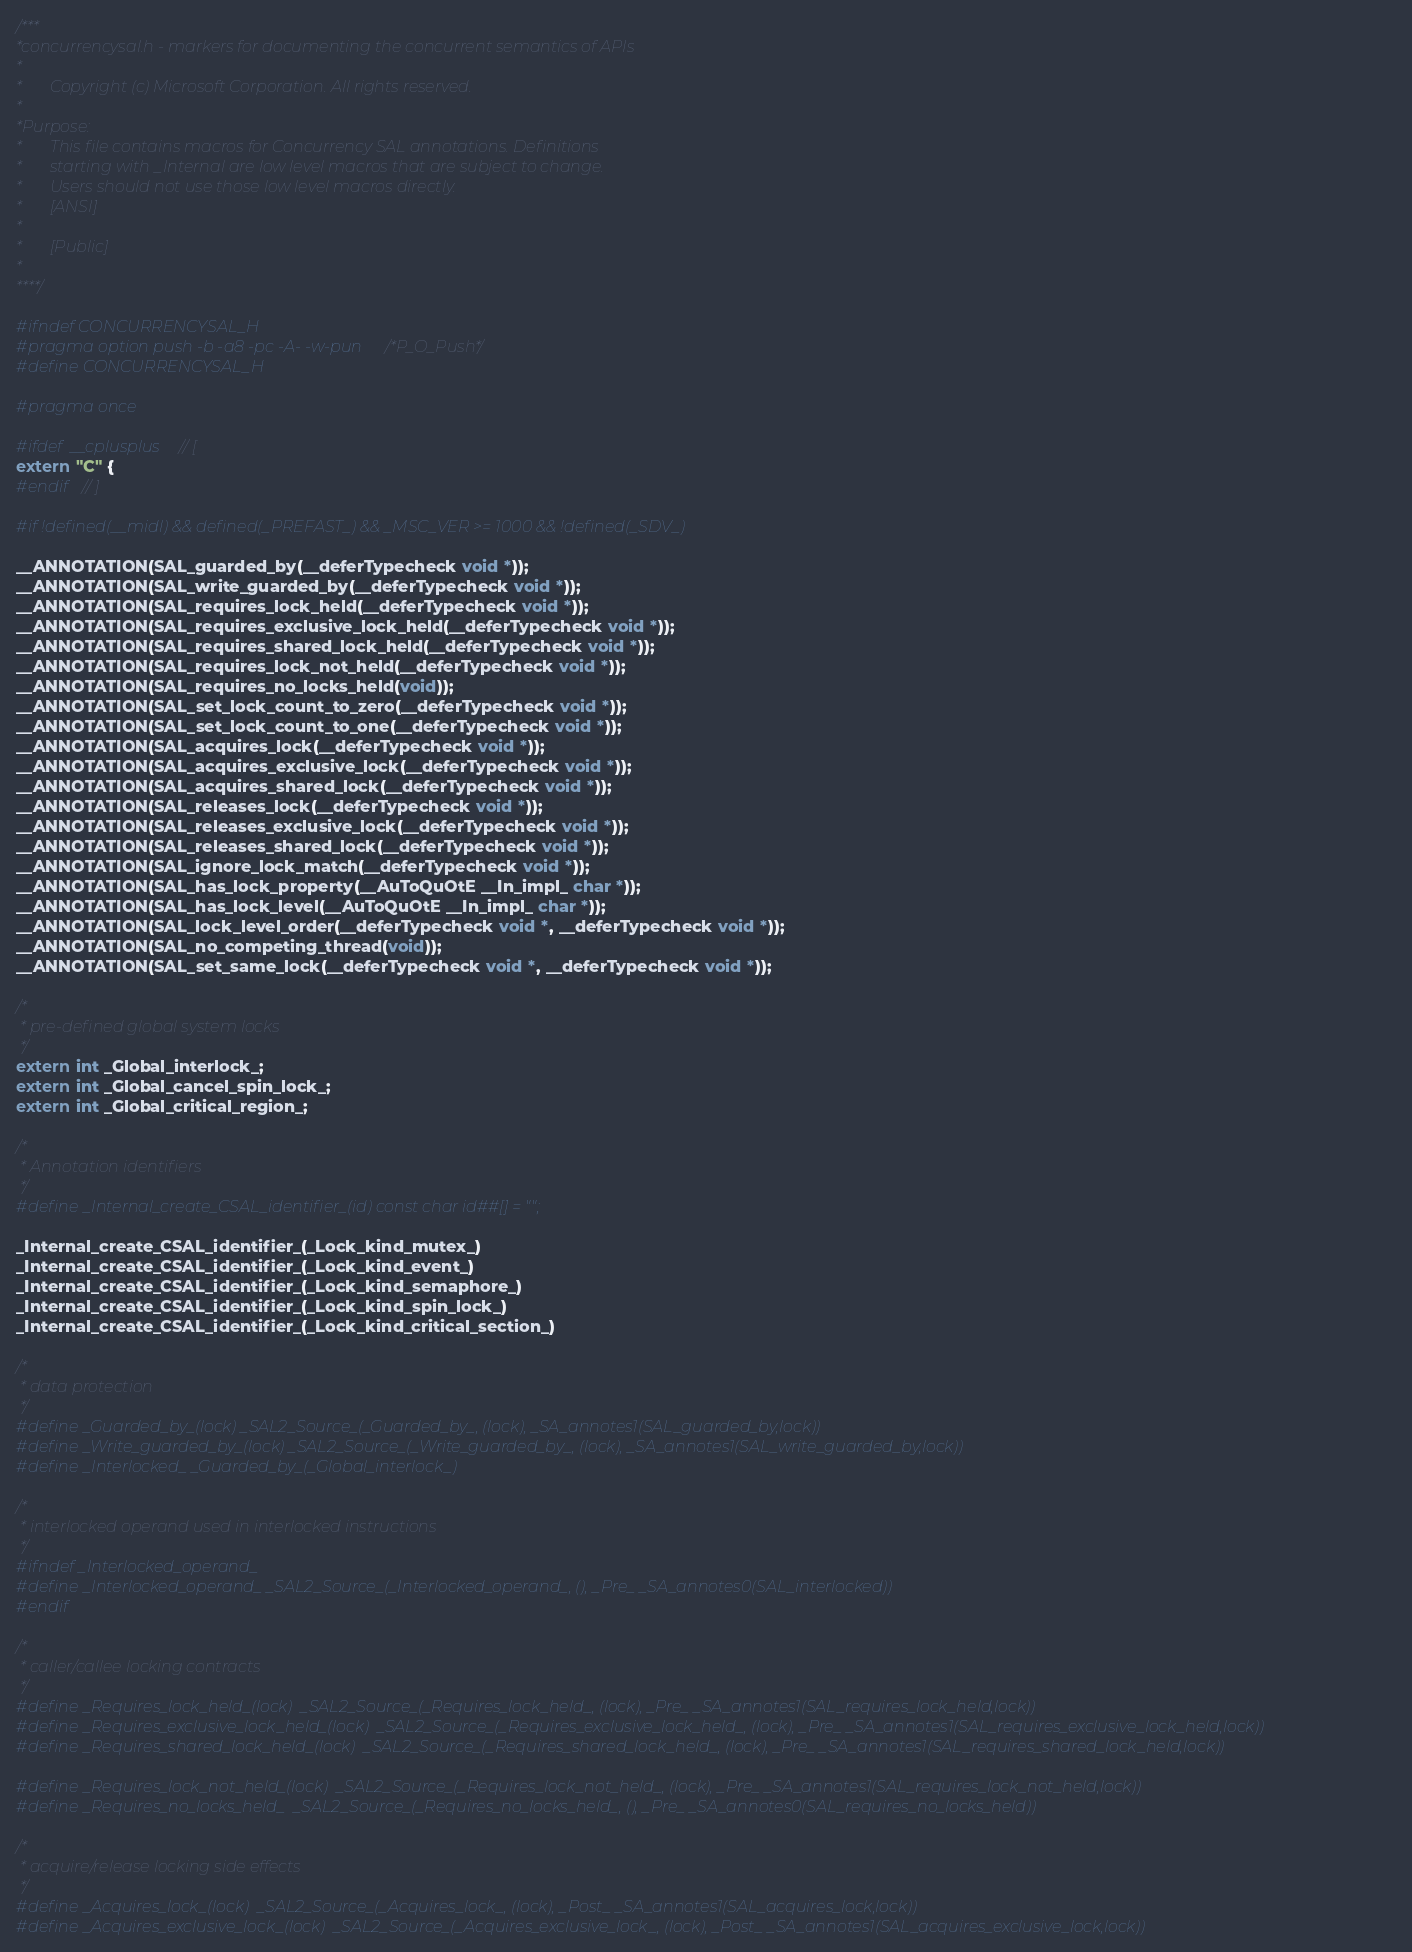Convert code to text. <code><loc_0><loc_0><loc_500><loc_500><_C_>/***
*concurrencysal.h - markers for documenting the concurrent semantics of APIs
*
*       Copyright (c) Microsoft Corporation. All rights reserved.
*
*Purpose:
*       This file contains macros for Concurrency SAL annotations. Definitions
*       starting with _Internal are low level macros that are subject to change. 
*       Users should not use those low level macros directly.
*       [ANSI]
*
*       [Public]
*
****/

#ifndef CONCURRENCYSAL_H
#pragma option push -b -a8 -pc -A- -w-pun /*P_O_Push*/
#define CONCURRENCYSAL_H

#pragma once

#ifdef  __cplusplus // [
extern "C" {
#endif  // ]

#if !defined(__midl) && defined(_PREFAST_) && _MSC_VER >= 1000 && !defined(_SDV_)

__ANNOTATION(SAL_guarded_by(__deferTypecheck void *));
__ANNOTATION(SAL_write_guarded_by(__deferTypecheck void *));
__ANNOTATION(SAL_requires_lock_held(__deferTypecheck void *));
__ANNOTATION(SAL_requires_exclusive_lock_held(__deferTypecheck void *));
__ANNOTATION(SAL_requires_shared_lock_held(__deferTypecheck void *));
__ANNOTATION(SAL_requires_lock_not_held(__deferTypecheck void *));
__ANNOTATION(SAL_requires_no_locks_held(void));
__ANNOTATION(SAL_set_lock_count_to_zero(__deferTypecheck void *));
__ANNOTATION(SAL_set_lock_count_to_one(__deferTypecheck void *));
__ANNOTATION(SAL_acquires_lock(__deferTypecheck void *));
__ANNOTATION(SAL_acquires_exclusive_lock(__deferTypecheck void *));
__ANNOTATION(SAL_acquires_shared_lock(__deferTypecheck void *));
__ANNOTATION(SAL_releases_lock(__deferTypecheck void *));
__ANNOTATION(SAL_releases_exclusive_lock(__deferTypecheck void *));
__ANNOTATION(SAL_releases_shared_lock(__deferTypecheck void *));
__ANNOTATION(SAL_ignore_lock_match(__deferTypecheck void *));
__ANNOTATION(SAL_has_lock_property(__AuToQuOtE __In_impl_ char *));
__ANNOTATION(SAL_has_lock_level(__AuToQuOtE __In_impl_ char *));
__ANNOTATION(SAL_lock_level_order(__deferTypecheck void *, __deferTypecheck void *));
__ANNOTATION(SAL_no_competing_thread(void));
__ANNOTATION(SAL_set_same_lock(__deferTypecheck void *, __deferTypecheck void *));

/*
 * pre-defined global system locks
 */
extern int _Global_interlock_;
extern int _Global_cancel_spin_lock_;
extern int _Global_critical_region_;

/*
 * Annotation identifiers
 */
#define _Internal_create_CSAL_identifier_(id) const char id##[] = "";

_Internal_create_CSAL_identifier_(_Lock_kind_mutex_)
_Internal_create_CSAL_identifier_(_Lock_kind_event_)
_Internal_create_CSAL_identifier_(_Lock_kind_semaphore_)
_Internal_create_CSAL_identifier_(_Lock_kind_spin_lock_)
_Internal_create_CSAL_identifier_(_Lock_kind_critical_section_)

/*
 * data protection
 */
#define _Guarded_by_(lock) _SAL2_Source_(_Guarded_by_, (lock), _SA_annotes1(SAL_guarded_by,lock))
#define _Write_guarded_by_(lock) _SAL2_Source_(_Write_guarded_by_, (lock), _SA_annotes1(SAL_write_guarded_by,lock))
#define _Interlocked_ _Guarded_by_(_Global_interlock_)

/*
 * interlocked operand used in interlocked instructions
 */
#ifndef _Interlocked_operand_
#define _Interlocked_operand_ _SAL2_Source_(_Interlocked_operand_, (), _Pre_ _SA_annotes0(SAL_interlocked))
#endif

/*
 * caller/callee locking contracts
 */
#define _Requires_lock_held_(lock)  _SAL2_Source_(_Requires_lock_held_, (lock), _Pre_ _SA_annotes1(SAL_requires_lock_held,lock))
#define _Requires_exclusive_lock_held_(lock)  _SAL2_Source_(_Requires_exclusive_lock_held_, (lock), _Pre_ _SA_annotes1(SAL_requires_exclusive_lock_held,lock))
#define _Requires_shared_lock_held_(lock)  _SAL2_Source_(_Requires_shared_lock_held_, (lock), _Pre_ _SA_annotes1(SAL_requires_shared_lock_held,lock))

#define _Requires_lock_not_held_(lock)  _SAL2_Source_(_Requires_lock_not_held_, (lock), _Pre_ _SA_annotes1(SAL_requires_lock_not_held,lock))
#define _Requires_no_locks_held_  _SAL2_Source_(_Requires_no_locks_held_, (), _Pre_ _SA_annotes0(SAL_requires_no_locks_held))

/*
 * acquire/release locking side effects
 */
#define _Acquires_lock_(lock)  _SAL2_Source_(_Acquires_lock_, (lock), _Post_ _SA_annotes1(SAL_acquires_lock,lock))
#define _Acquires_exclusive_lock_(lock)  _SAL2_Source_(_Acquires_exclusive_lock_, (lock), _Post_ _SA_annotes1(SAL_acquires_exclusive_lock,lock))</code> 